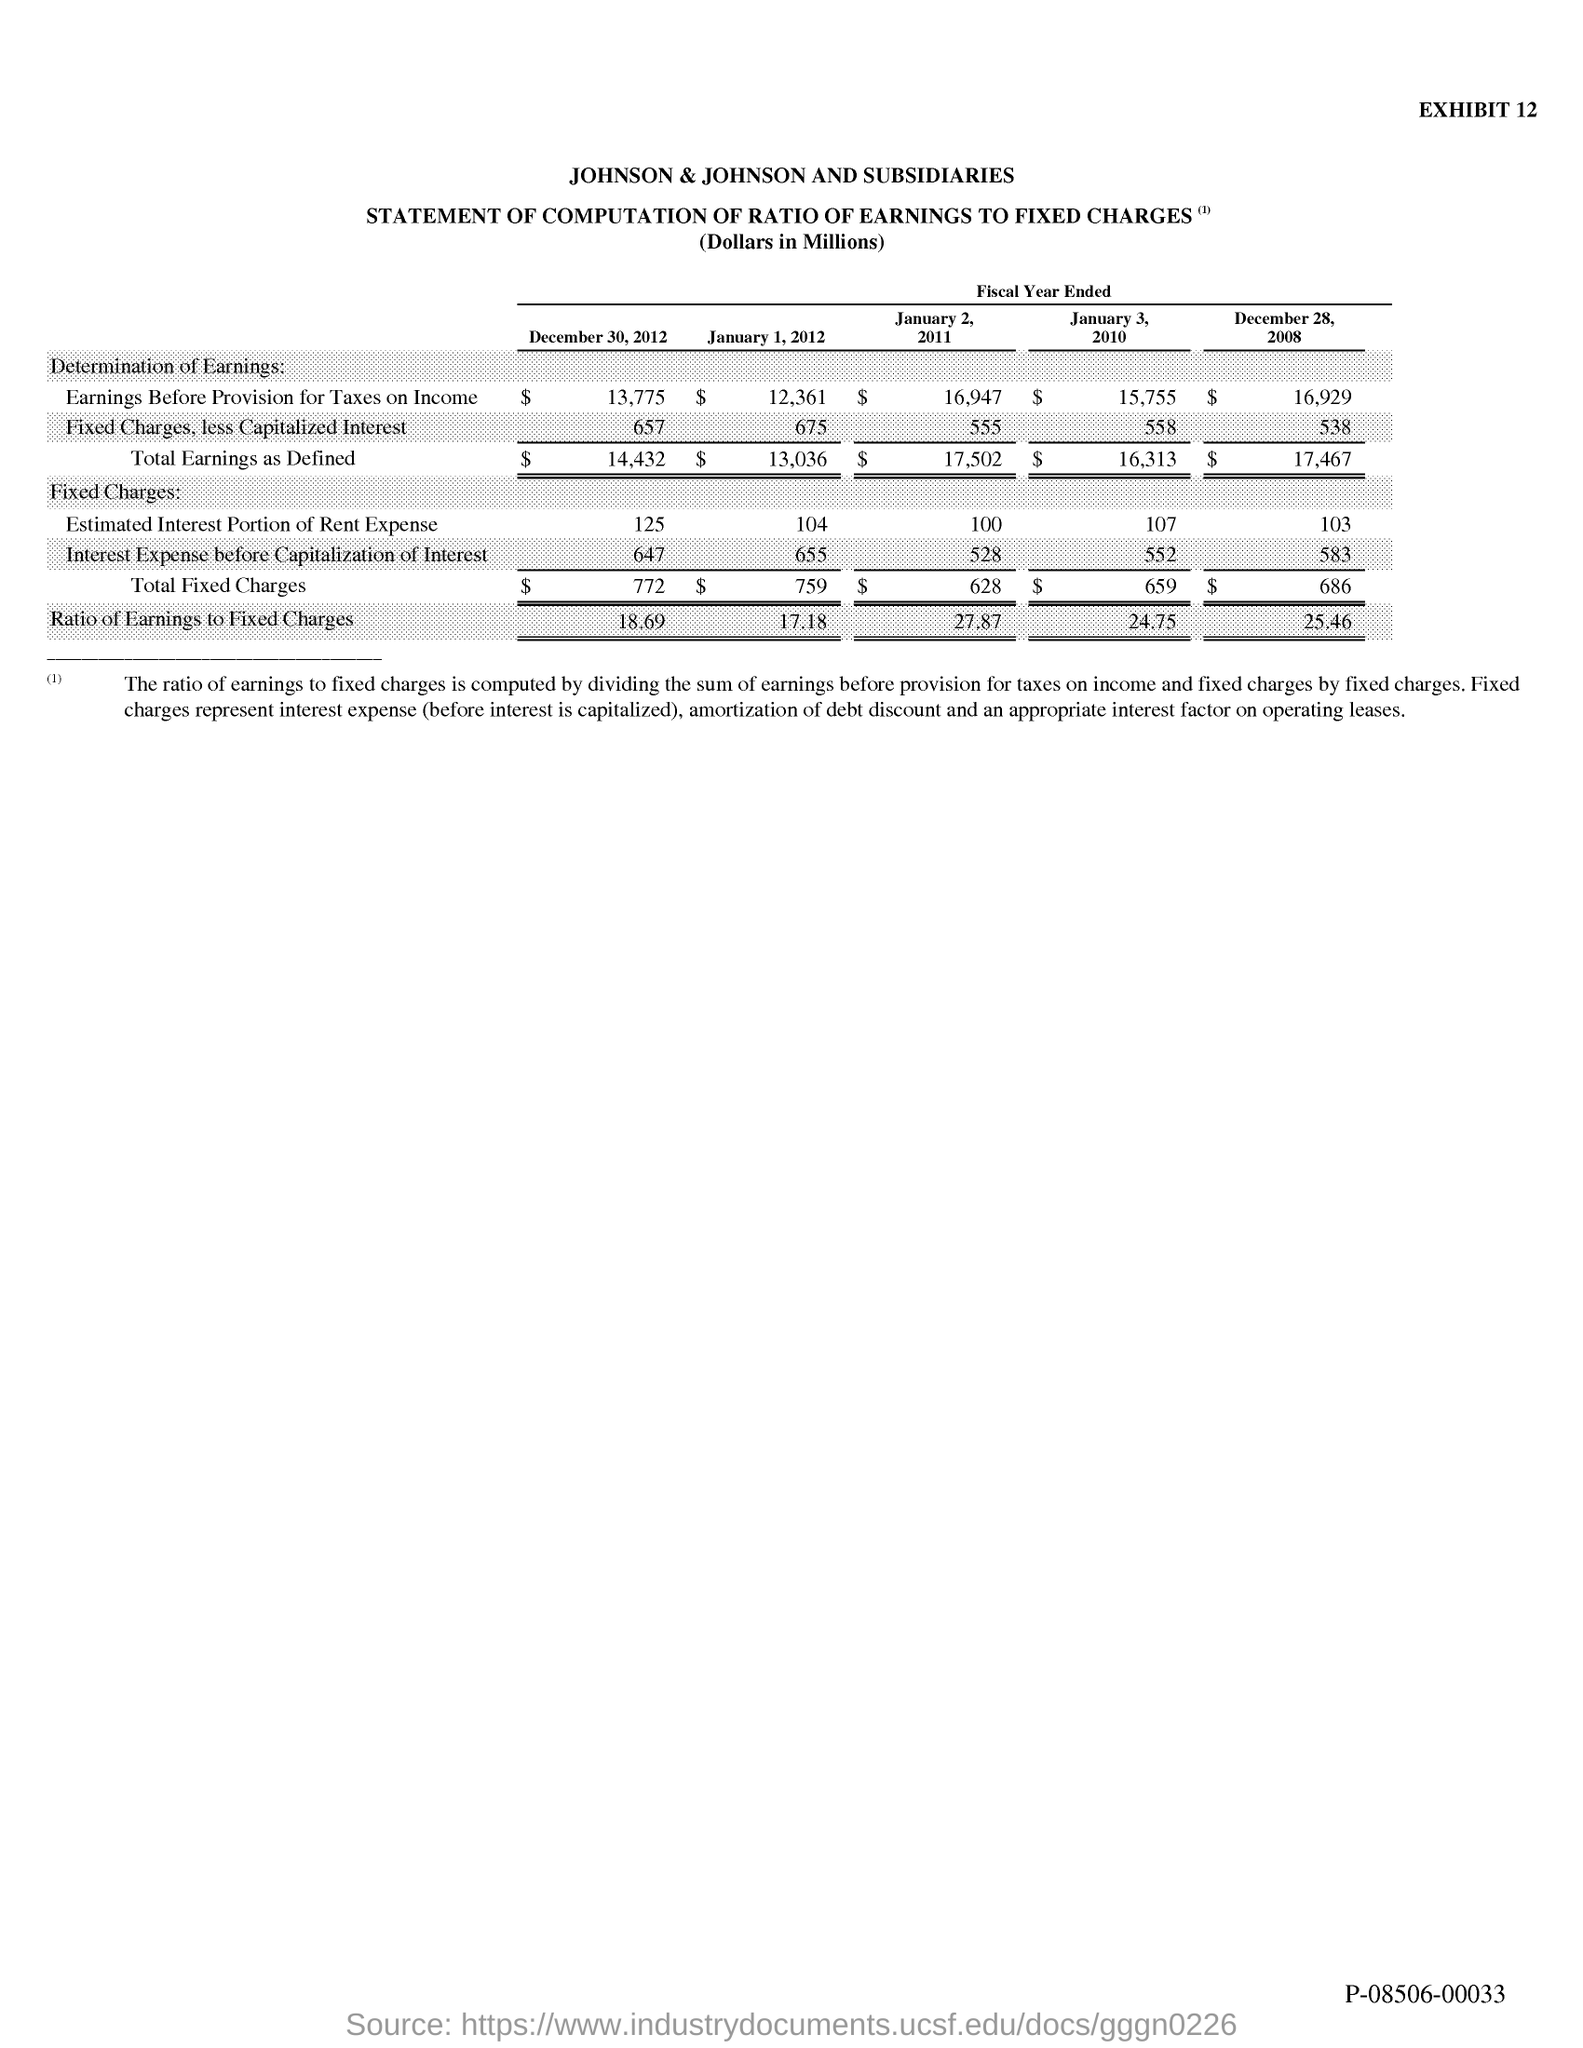Draw attention to some important aspects in this diagram. The exhibit number is 12. 